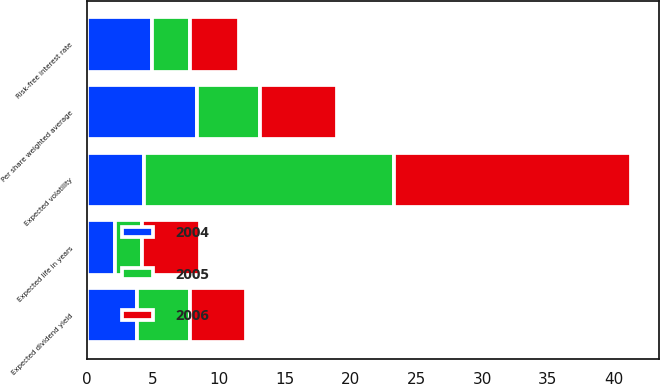<chart> <loc_0><loc_0><loc_500><loc_500><stacked_bar_chart><ecel><fcel>Per share weighted average<fcel>Expected dividend yield<fcel>Risk-free interest rate<fcel>Expected volatility<fcel>Expected life in years<nl><fcel>2004<fcel>8.35<fcel>3.8<fcel>4.9<fcel>4.35<fcel>2.1<nl><fcel>2006<fcel>5.91<fcel>4.3<fcel>3.7<fcel>18<fcel>4.4<nl><fcel>2005<fcel>4.75<fcel>4<fcel>2.9<fcel>19<fcel>2.1<nl></chart> 